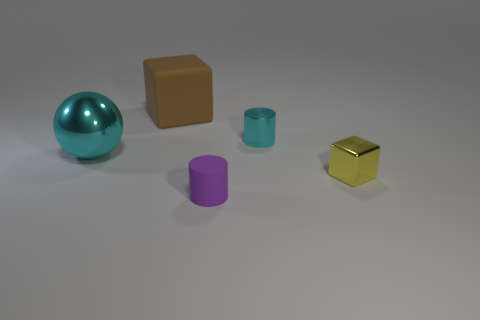Are there any other things that have the same shape as the large cyan object?
Your answer should be very brief. No. What is the color of the sphere that is made of the same material as the yellow object?
Make the answer very short. Cyan. Are there more matte cylinders than tiny objects?
Ensure brevity in your answer.  No. There is a thing that is left of the purple thing and in front of the brown thing; how big is it?
Offer a very short reply. Large. There is a cylinder that is the same color as the large metal sphere; what material is it?
Give a very brief answer. Metal. Are there the same number of large shiny objects to the left of the large cyan sphere and tiny gray metal spheres?
Provide a short and direct response. Yes. Do the brown matte block and the cyan metallic cylinder have the same size?
Offer a terse response. No. There is a thing that is right of the large cyan sphere and to the left of the tiny purple rubber thing; what is its color?
Offer a very short reply. Brown. What is the material of the cyan object that is on the left side of the small cylinder in front of the yellow metal block?
Your answer should be compact. Metal. There is a brown thing that is the same shape as the tiny yellow object; what is its size?
Give a very brief answer. Large. 